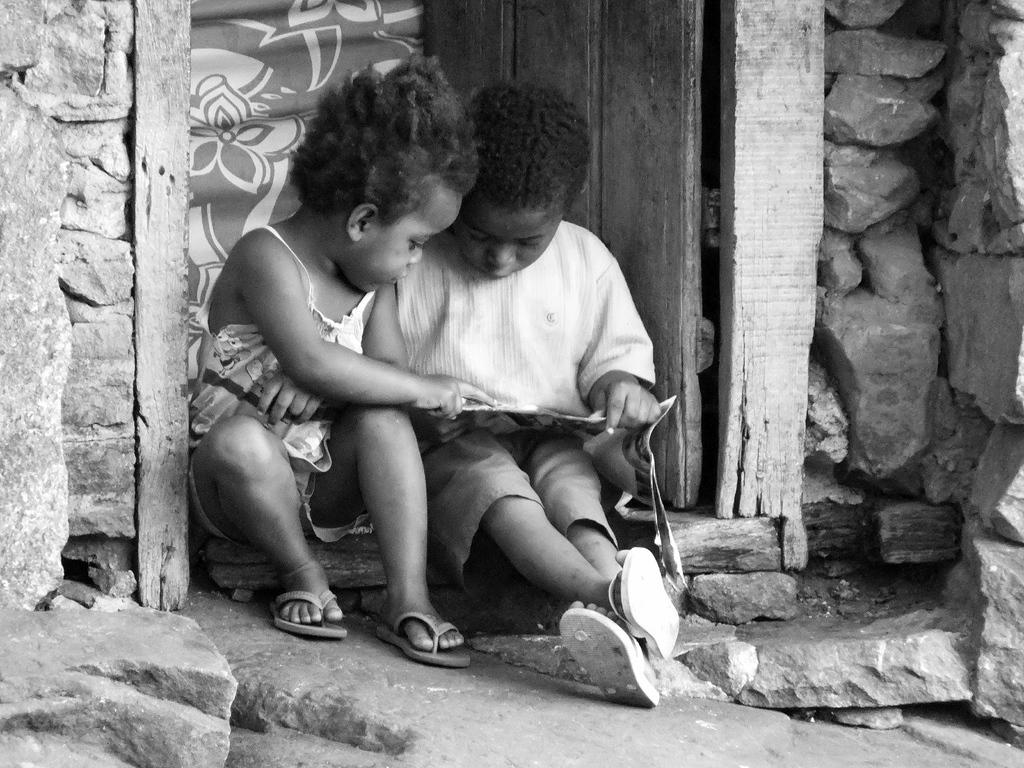What is the color scheme of the image? The image is black and white. What can be seen in the center of the image? There are two kids in the center of the image. What are the kids holding? The kids are holding a paper. Where are the kids sitting? The kids are sitting on the ground. What can be seen in the background of the image? There is a door visible in the background, and there are stone walls. What type of root can be seen growing near the kids in the image? There are no roots visible in the image; the kids are sitting on the ground, and there is no indication of any plant life nearby. 